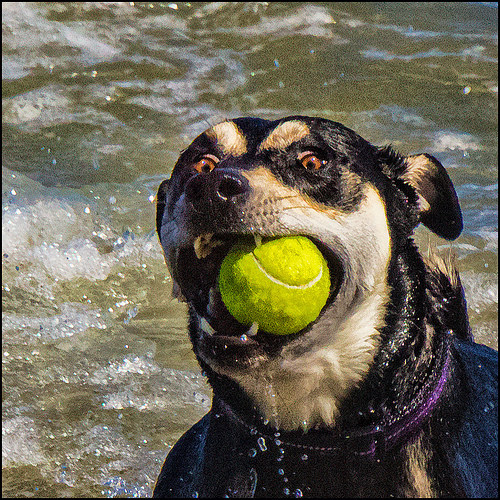<image>
Is the ball in the water? No. The ball is not contained within the water. These objects have a different spatial relationship. 